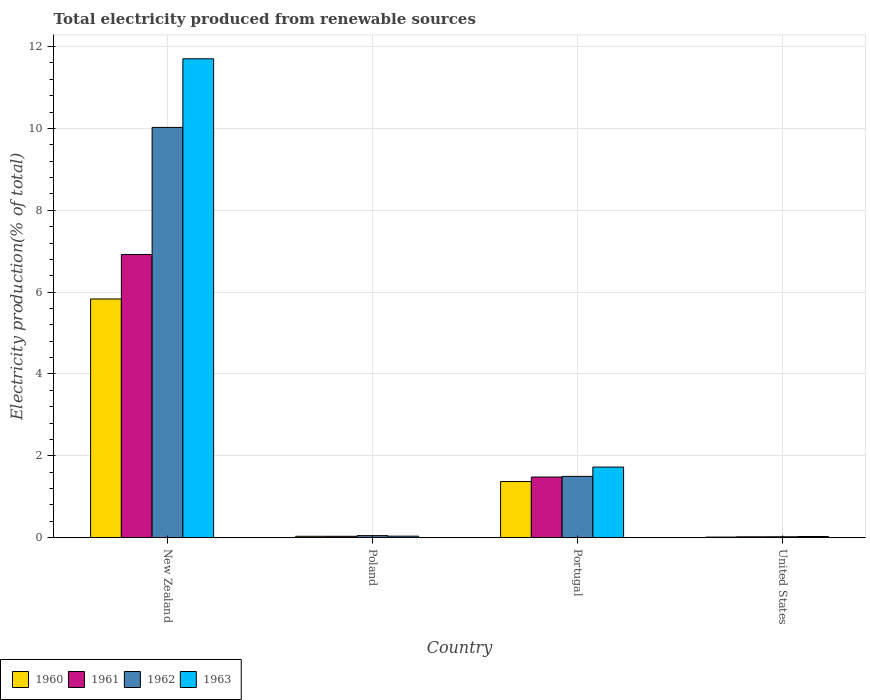How many groups of bars are there?
Your answer should be compact. 4. Are the number of bars per tick equal to the number of legend labels?
Your response must be concise. Yes. How many bars are there on the 3rd tick from the right?
Give a very brief answer. 4. In how many cases, is the number of bars for a given country not equal to the number of legend labels?
Provide a succinct answer. 0. What is the total electricity produced in 1963 in Portugal?
Ensure brevity in your answer.  1.73. Across all countries, what is the maximum total electricity produced in 1963?
Your answer should be compact. 11.7. Across all countries, what is the minimum total electricity produced in 1963?
Provide a short and direct response. 0.03. In which country was the total electricity produced in 1963 maximum?
Provide a short and direct response. New Zealand. In which country was the total electricity produced in 1960 minimum?
Provide a succinct answer. United States. What is the total total electricity produced in 1960 in the graph?
Offer a very short reply. 7.25. What is the difference between the total electricity produced in 1960 in New Zealand and that in Poland?
Give a very brief answer. 5.8. What is the difference between the total electricity produced in 1963 in Poland and the total electricity produced in 1962 in New Zealand?
Provide a succinct answer. -9.99. What is the average total electricity produced in 1962 per country?
Your answer should be compact. 2.9. What is the difference between the total electricity produced of/in 1961 and total electricity produced of/in 1960 in Portugal?
Keep it short and to the point. 0.11. In how many countries, is the total electricity produced in 1962 greater than 11.6 %?
Make the answer very short. 0. What is the ratio of the total electricity produced in 1960 in New Zealand to that in Portugal?
Make the answer very short. 4.25. Is the total electricity produced in 1962 in Portugal less than that in United States?
Your response must be concise. No. What is the difference between the highest and the second highest total electricity produced in 1963?
Your response must be concise. -1.69. What is the difference between the highest and the lowest total electricity produced in 1963?
Provide a succinct answer. 11.67. In how many countries, is the total electricity produced in 1963 greater than the average total electricity produced in 1963 taken over all countries?
Ensure brevity in your answer.  1. Is it the case that in every country, the sum of the total electricity produced in 1961 and total electricity produced in 1962 is greater than the sum of total electricity produced in 1960 and total electricity produced in 1963?
Ensure brevity in your answer.  No. What does the 2nd bar from the left in United States represents?
Ensure brevity in your answer.  1961. What does the 3rd bar from the right in Poland represents?
Provide a succinct answer. 1961. How many bars are there?
Give a very brief answer. 16. Are the values on the major ticks of Y-axis written in scientific E-notation?
Give a very brief answer. No. Does the graph contain any zero values?
Your answer should be very brief. No. Does the graph contain grids?
Your response must be concise. Yes. How are the legend labels stacked?
Offer a very short reply. Horizontal. What is the title of the graph?
Offer a very short reply. Total electricity produced from renewable sources. What is the label or title of the X-axis?
Make the answer very short. Country. What is the label or title of the Y-axis?
Offer a very short reply. Electricity production(% of total). What is the Electricity production(% of total) in 1960 in New Zealand?
Offer a terse response. 5.83. What is the Electricity production(% of total) of 1961 in New Zealand?
Your answer should be very brief. 6.92. What is the Electricity production(% of total) in 1962 in New Zealand?
Your response must be concise. 10.02. What is the Electricity production(% of total) in 1963 in New Zealand?
Keep it short and to the point. 11.7. What is the Electricity production(% of total) in 1960 in Poland?
Ensure brevity in your answer.  0.03. What is the Electricity production(% of total) in 1961 in Poland?
Offer a very short reply. 0.03. What is the Electricity production(% of total) in 1962 in Poland?
Provide a short and direct response. 0.05. What is the Electricity production(% of total) in 1963 in Poland?
Offer a terse response. 0.04. What is the Electricity production(% of total) in 1960 in Portugal?
Offer a very short reply. 1.37. What is the Electricity production(% of total) in 1961 in Portugal?
Keep it short and to the point. 1.48. What is the Electricity production(% of total) in 1962 in Portugal?
Provide a succinct answer. 1.5. What is the Electricity production(% of total) in 1963 in Portugal?
Provide a succinct answer. 1.73. What is the Electricity production(% of total) in 1960 in United States?
Provide a succinct answer. 0.02. What is the Electricity production(% of total) of 1961 in United States?
Keep it short and to the point. 0.02. What is the Electricity production(% of total) in 1962 in United States?
Offer a terse response. 0.02. What is the Electricity production(% of total) in 1963 in United States?
Ensure brevity in your answer.  0.03. Across all countries, what is the maximum Electricity production(% of total) in 1960?
Provide a succinct answer. 5.83. Across all countries, what is the maximum Electricity production(% of total) of 1961?
Ensure brevity in your answer.  6.92. Across all countries, what is the maximum Electricity production(% of total) of 1962?
Ensure brevity in your answer.  10.02. Across all countries, what is the maximum Electricity production(% of total) in 1963?
Offer a terse response. 11.7. Across all countries, what is the minimum Electricity production(% of total) of 1960?
Keep it short and to the point. 0.02. Across all countries, what is the minimum Electricity production(% of total) of 1961?
Offer a terse response. 0.02. Across all countries, what is the minimum Electricity production(% of total) of 1962?
Give a very brief answer. 0.02. Across all countries, what is the minimum Electricity production(% of total) of 1963?
Ensure brevity in your answer.  0.03. What is the total Electricity production(% of total) of 1960 in the graph?
Your answer should be very brief. 7.25. What is the total Electricity production(% of total) in 1961 in the graph?
Keep it short and to the point. 8.46. What is the total Electricity production(% of total) in 1962 in the graph?
Your answer should be compact. 11.6. What is the total Electricity production(% of total) of 1963 in the graph?
Your response must be concise. 13.49. What is the difference between the Electricity production(% of total) of 1960 in New Zealand and that in Poland?
Make the answer very short. 5.8. What is the difference between the Electricity production(% of total) in 1961 in New Zealand and that in Poland?
Provide a short and direct response. 6.89. What is the difference between the Electricity production(% of total) in 1962 in New Zealand and that in Poland?
Provide a short and direct response. 9.97. What is the difference between the Electricity production(% of total) in 1963 in New Zealand and that in Poland?
Your answer should be very brief. 11.66. What is the difference between the Electricity production(% of total) in 1960 in New Zealand and that in Portugal?
Keep it short and to the point. 4.46. What is the difference between the Electricity production(% of total) in 1961 in New Zealand and that in Portugal?
Offer a terse response. 5.44. What is the difference between the Electricity production(% of total) of 1962 in New Zealand and that in Portugal?
Provide a succinct answer. 8.53. What is the difference between the Electricity production(% of total) of 1963 in New Zealand and that in Portugal?
Your response must be concise. 9.97. What is the difference between the Electricity production(% of total) of 1960 in New Zealand and that in United States?
Your answer should be compact. 5.82. What is the difference between the Electricity production(% of total) in 1961 in New Zealand and that in United States?
Your answer should be very brief. 6.9. What is the difference between the Electricity production(% of total) of 1962 in New Zealand and that in United States?
Offer a very short reply. 10. What is the difference between the Electricity production(% of total) of 1963 in New Zealand and that in United States?
Your answer should be compact. 11.67. What is the difference between the Electricity production(% of total) in 1960 in Poland and that in Portugal?
Make the answer very short. -1.34. What is the difference between the Electricity production(% of total) in 1961 in Poland and that in Portugal?
Offer a terse response. -1.45. What is the difference between the Electricity production(% of total) of 1962 in Poland and that in Portugal?
Your answer should be very brief. -1.45. What is the difference between the Electricity production(% of total) in 1963 in Poland and that in Portugal?
Keep it short and to the point. -1.69. What is the difference between the Electricity production(% of total) in 1960 in Poland and that in United States?
Your answer should be compact. 0.02. What is the difference between the Electricity production(% of total) of 1961 in Poland and that in United States?
Provide a short and direct response. 0.01. What is the difference between the Electricity production(% of total) in 1962 in Poland and that in United States?
Your response must be concise. 0.03. What is the difference between the Electricity production(% of total) in 1963 in Poland and that in United States?
Offer a very short reply. 0.01. What is the difference between the Electricity production(% of total) in 1960 in Portugal and that in United States?
Your response must be concise. 1.36. What is the difference between the Electricity production(% of total) of 1961 in Portugal and that in United States?
Your answer should be compact. 1.46. What is the difference between the Electricity production(% of total) of 1962 in Portugal and that in United States?
Ensure brevity in your answer.  1.48. What is the difference between the Electricity production(% of total) of 1963 in Portugal and that in United States?
Ensure brevity in your answer.  1.7. What is the difference between the Electricity production(% of total) in 1960 in New Zealand and the Electricity production(% of total) in 1961 in Poland?
Make the answer very short. 5.8. What is the difference between the Electricity production(% of total) in 1960 in New Zealand and the Electricity production(% of total) in 1962 in Poland?
Provide a short and direct response. 5.78. What is the difference between the Electricity production(% of total) of 1960 in New Zealand and the Electricity production(% of total) of 1963 in Poland?
Provide a short and direct response. 5.79. What is the difference between the Electricity production(% of total) of 1961 in New Zealand and the Electricity production(% of total) of 1962 in Poland?
Keep it short and to the point. 6.87. What is the difference between the Electricity production(% of total) in 1961 in New Zealand and the Electricity production(% of total) in 1963 in Poland?
Offer a very short reply. 6.88. What is the difference between the Electricity production(% of total) in 1962 in New Zealand and the Electricity production(% of total) in 1963 in Poland?
Keep it short and to the point. 9.99. What is the difference between the Electricity production(% of total) in 1960 in New Zealand and the Electricity production(% of total) in 1961 in Portugal?
Your answer should be compact. 4.35. What is the difference between the Electricity production(% of total) of 1960 in New Zealand and the Electricity production(% of total) of 1962 in Portugal?
Offer a very short reply. 4.33. What is the difference between the Electricity production(% of total) in 1960 in New Zealand and the Electricity production(% of total) in 1963 in Portugal?
Offer a very short reply. 4.11. What is the difference between the Electricity production(% of total) of 1961 in New Zealand and the Electricity production(% of total) of 1962 in Portugal?
Offer a terse response. 5.42. What is the difference between the Electricity production(% of total) of 1961 in New Zealand and the Electricity production(% of total) of 1963 in Portugal?
Ensure brevity in your answer.  5.19. What is the difference between the Electricity production(% of total) of 1962 in New Zealand and the Electricity production(% of total) of 1963 in Portugal?
Offer a very short reply. 8.3. What is the difference between the Electricity production(% of total) of 1960 in New Zealand and the Electricity production(% of total) of 1961 in United States?
Provide a succinct answer. 5.81. What is the difference between the Electricity production(% of total) of 1960 in New Zealand and the Electricity production(% of total) of 1962 in United States?
Your response must be concise. 5.81. What is the difference between the Electricity production(% of total) in 1960 in New Zealand and the Electricity production(% of total) in 1963 in United States?
Offer a very short reply. 5.8. What is the difference between the Electricity production(% of total) in 1961 in New Zealand and the Electricity production(% of total) in 1962 in United States?
Provide a short and direct response. 6.9. What is the difference between the Electricity production(% of total) in 1961 in New Zealand and the Electricity production(% of total) in 1963 in United States?
Make the answer very short. 6.89. What is the difference between the Electricity production(% of total) of 1962 in New Zealand and the Electricity production(% of total) of 1963 in United States?
Ensure brevity in your answer.  10. What is the difference between the Electricity production(% of total) of 1960 in Poland and the Electricity production(% of total) of 1961 in Portugal?
Your answer should be very brief. -1.45. What is the difference between the Electricity production(% of total) of 1960 in Poland and the Electricity production(% of total) of 1962 in Portugal?
Provide a short and direct response. -1.46. What is the difference between the Electricity production(% of total) of 1960 in Poland and the Electricity production(% of total) of 1963 in Portugal?
Give a very brief answer. -1.69. What is the difference between the Electricity production(% of total) of 1961 in Poland and the Electricity production(% of total) of 1962 in Portugal?
Your response must be concise. -1.46. What is the difference between the Electricity production(% of total) in 1961 in Poland and the Electricity production(% of total) in 1963 in Portugal?
Offer a terse response. -1.69. What is the difference between the Electricity production(% of total) in 1962 in Poland and the Electricity production(% of total) in 1963 in Portugal?
Provide a succinct answer. -1.67. What is the difference between the Electricity production(% of total) in 1960 in Poland and the Electricity production(% of total) in 1961 in United States?
Give a very brief answer. 0.01. What is the difference between the Electricity production(% of total) in 1960 in Poland and the Electricity production(% of total) in 1962 in United States?
Keep it short and to the point. 0.01. What is the difference between the Electricity production(% of total) of 1960 in Poland and the Electricity production(% of total) of 1963 in United States?
Your answer should be compact. 0. What is the difference between the Electricity production(% of total) in 1961 in Poland and the Electricity production(% of total) in 1962 in United States?
Make the answer very short. 0.01. What is the difference between the Electricity production(% of total) of 1961 in Poland and the Electricity production(% of total) of 1963 in United States?
Keep it short and to the point. 0. What is the difference between the Electricity production(% of total) of 1962 in Poland and the Electricity production(% of total) of 1963 in United States?
Your answer should be compact. 0.02. What is the difference between the Electricity production(% of total) of 1960 in Portugal and the Electricity production(% of total) of 1961 in United States?
Provide a succinct answer. 1.35. What is the difference between the Electricity production(% of total) in 1960 in Portugal and the Electricity production(% of total) in 1962 in United States?
Your response must be concise. 1.35. What is the difference between the Electricity production(% of total) in 1960 in Portugal and the Electricity production(% of total) in 1963 in United States?
Ensure brevity in your answer.  1.34. What is the difference between the Electricity production(% of total) of 1961 in Portugal and the Electricity production(% of total) of 1962 in United States?
Provide a short and direct response. 1.46. What is the difference between the Electricity production(% of total) in 1961 in Portugal and the Electricity production(% of total) in 1963 in United States?
Your answer should be very brief. 1.45. What is the difference between the Electricity production(% of total) of 1962 in Portugal and the Electricity production(% of total) of 1963 in United States?
Give a very brief answer. 1.47. What is the average Electricity production(% of total) of 1960 per country?
Your answer should be compact. 1.81. What is the average Electricity production(% of total) of 1961 per country?
Give a very brief answer. 2.11. What is the average Electricity production(% of total) of 1962 per country?
Provide a succinct answer. 2.9. What is the average Electricity production(% of total) in 1963 per country?
Make the answer very short. 3.37. What is the difference between the Electricity production(% of total) of 1960 and Electricity production(% of total) of 1961 in New Zealand?
Your response must be concise. -1.09. What is the difference between the Electricity production(% of total) in 1960 and Electricity production(% of total) in 1962 in New Zealand?
Offer a terse response. -4.19. What is the difference between the Electricity production(% of total) in 1960 and Electricity production(% of total) in 1963 in New Zealand?
Offer a very short reply. -5.87. What is the difference between the Electricity production(% of total) in 1961 and Electricity production(% of total) in 1962 in New Zealand?
Your answer should be compact. -3.1. What is the difference between the Electricity production(% of total) of 1961 and Electricity production(% of total) of 1963 in New Zealand?
Your answer should be very brief. -4.78. What is the difference between the Electricity production(% of total) of 1962 and Electricity production(% of total) of 1963 in New Zealand?
Give a very brief answer. -1.68. What is the difference between the Electricity production(% of total) in 1960 and Electricity production(% of total) in 1961 in Poland?
Your answer should be compact. 0. What is the difference between the Electricity production(% of total) in 1960 and Electricity production(% of total) in 1962 in Poland?
Give a very brief answer. -0.02. What is the difference between the Electricity production(% of total) of 1960 and Electricity production(% of total) of 1963 in Poland?
Your answer should be very brief. -0. What is the difference between the Electricity production(% of total) of 1961 and Electricity production(% of total) of 1962 in Poland?
Provide a succinct answer. -0.02. What is the difference between the Electricity production(% of total) of 1961 and Electricity production(% of total) of 1963 in Poland?
Your response must be concise. -0. What is the difference between the Electricity production(% of total) of 1962 and Electricity production(% of total) of 1963 in Poland?
Offer a terse response. 0.01. What is the difference between the Electricity production(% of total) of 1960 and Electricity production(% of total) of 1961 in Portugal?
Your answer should be compact. -0.11. What is the difference between the Electricity production(% of total) in 1960 and Electricity production(% of total) in 1962 in Portugal?
Your answer should be very brief. -0.13. What is the difference between the Electricity production(% of total) of 1960 and Electricity production(% of total) of 1963 in Portugal?
Your answer should be very brief. -0.35. What is the difference between the Electricity production(% of total) in 1961 and Electricity production(% of total) in 1962 in Portugal?
Ensure brevity in your answer.  -0.02. What is the difference between the Electricity production(% of total) of 1961 and Electricity production(% of total) of 1963 in Portugal?
Your answer should be compact. -0.24. What is the difference between the Electricity production(% of total) of 1962 and Electricity production(% of total) of 1963 in Portugal?
Provide a succinct answer. -0.23. What is the difference between the Electricity production(% of total) of 1960 and Electricity production(% of total) of 1961 in United States?
Your answer should be compact. -0.01. What is the difference between the Electricity production(% of total) of 1960 and Electricity production(% of total) of 1962 in United States?
Offer a terse response. -0.01. What is the difference between the Electricity production(% of total) of 1960 and Electricity production(% of total) of 1963 in United States?
Ensure brevity in your answer.  -0.01. What is the difference between the Electricity production(% of total) of 1961 and Electricity production(% of total) of 1962 in United States?
Offer a very short reply. -0. What is the difference between the Electricity production(% of total) of 1961 and Electricity production(% of total) of 1963 in United States?
Provide a short and direct response. -0.01. What is the difference between the Electricity production(% of total) of 1962 and Electricity production(% of total) of 1963 in United States?
Offer a terse response. -0.01. What is the ratio of the Electricity production(% of total) of 1960 in New Zealand to that in Poland?
Your answer should be compact. 170.79. What is the ratio of the Electricity production(% of total) of 1961 in New Zealand to that in Poland?
Provide a short and direct response. 202.83. What is the ratio of the Electricity production(% of total) of 1962 in New Zealand to that in Poland?
Your response must be concise. 196.95. What is the ratio of the Electricity production(% of total) of 1963 in New Zealand to that in Poland?
Offer a terse response. 308.73. What is the ratio of the Electricity production(% of total) of 1960 in New Zealand to that in Portugal?
Your answer should be compact. 4.25. What is the ratio of the Electricity production(% of total) in 1961 in New Zealand to that in Portugal?
Provide a succinct answer. 4.67. What is the ratio of the Electricity production(% of total) of 1962 in New Zealand to that in Portugal?
Your answer should be compact. 6.69. What is the ratio of the Electricity production(% of total) of 1963 in New Zealand to that in Portugal?
Make the answer very short. 6.78. What is the ratio of the Electricity production(% of total) of 1960 in New Zealand to that in United States?
Make the answer very short. 382.31. What is the ratio of the Electricity production(% of total) in 1961 in New Zealand to that in United States?
Your answer should be very brief. 321.25. What is the ratio of the Electricity production(% of total) in 1962 in New Zealand to that in United States?
Your answer should be compact. 439.93. What is the ratio of the Electricity production(% of total) in 1963 in New Zealand to that in United States?
Provide a short and direct response. 397.5. What is the ratio of the Electricity production(% of total) of 1960 in Poland to that in Portugal?
Ensure brevity in your answer.  0.02. What is the ratio of the Electricity production(% of total) of 1961 in Poland to that in Portugal?
Provide a succinct answer. 0.02. What is the ratio of the Electricity production(% of total) in 1962 in Poland to that in Portugal?
Provide a short and direct response. 0.03. What is the ratio of the Electricity production(% of total) in 1963 in Poland to that in Portugal?
Provide a short and direct response. 0.02. What is the ratio of the Electricity production(% of total) of 1960 in Poland to that in United States?
Provide a short and direct response. 2.24. What is the ratio of the Electricity production(% of total) of 1961 in Poland to that in United States?
Make the answer very short. 1.58. What is the ratio of the Electricity production(% of total) in 1962 in Poland to that in United States?
Give a very brief answer. 2.23. What is the ratio of the Electricity production(% of total) in 1963 in Poland to that in United States?
Ensure brevity in your answer.  1.29. What is the ratio of the Electricity production(% of total) of 1960 in Portugal to that in United States?
Offer a terse response. 89.96. What is the ratio of the Electricity production(% of total) in 1961 in Portugal to that in United States?
Offer a very short reply. 68.83. What is the ratio of the Electricity production(% of total) of 1962 in Portugal to that in United States?
Make the answer very short. 65.74. What is the ratio of the Electricity production(% of total) of 1963 in Portugal to that in United States?
Keep it short and to the point. 58.63. What is the difference between the highest and the second highest Electricity production(% of total) in 1960?
Your answer should be very brief. 4.46. What is the difference between the highest and the second highest Electricity production(% of total) in 1961?
Make the answer very short. 5.44. What is the difference between the highest and the second highest Electricity production(% of total) of 1962?
Make the answer very short. 8.53. What is the difference between the highest and the second highest Electricity production(% of total) of 1963?
Provide a short and direct response. 9.97. What is the difference between the highest and the lowest Electricity production(% of total) of 1960?
Keep it short and to the point. 5.82. What is the difference between the highest and the lowest Electricity production(% of total) in 1961?
Your answer should be compact. 6.9. What is the difference between the highest and the lowest Electricity production(% of total) in 1962?
Provide a short and direct response. 10. What is the difference between the highest and the lowest Electricity production(% of total) of 1963?
Your answer should be very brief. 11.67. 